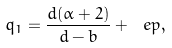Convert formula to latex. <formula><loc_0><loc_0><loc_500><loc_500>q _ { 1 } = \frac { d ( \alpha + 2 ) } { d - b } + \ e p ,</formula> 